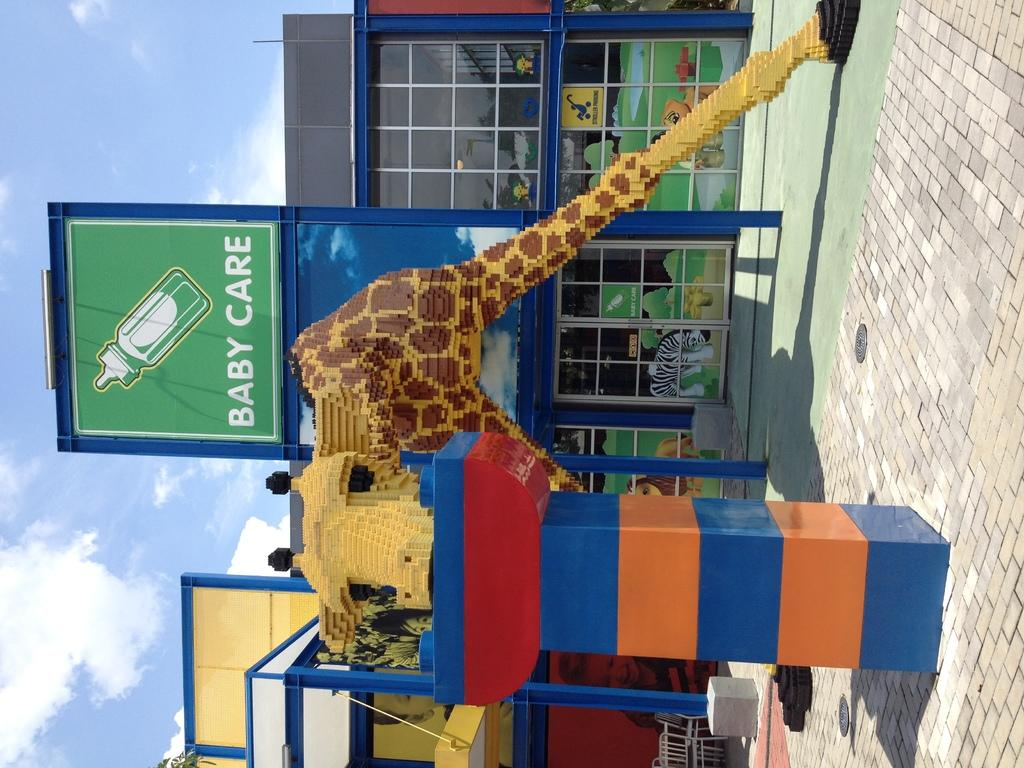What type of animal is depicted in the sculpture in the image? There is a sculpture of a giraffe in the image. Where is the sculpture located? The sculpture is on a surface in the image. What is the name of the shop visible in the image? The shop is called "baby care" in the image. How is the shop positioned in relation to the sculpture? The shop is behind the sculpture in the image. What can be seen in the background of the image? The sky is visible in the background of the image, and clouds are present. What type of desk can be seen in the image? There is no desk present in the image. What kind of laborer is working near the sculpture? There are no laborers present in the image. 